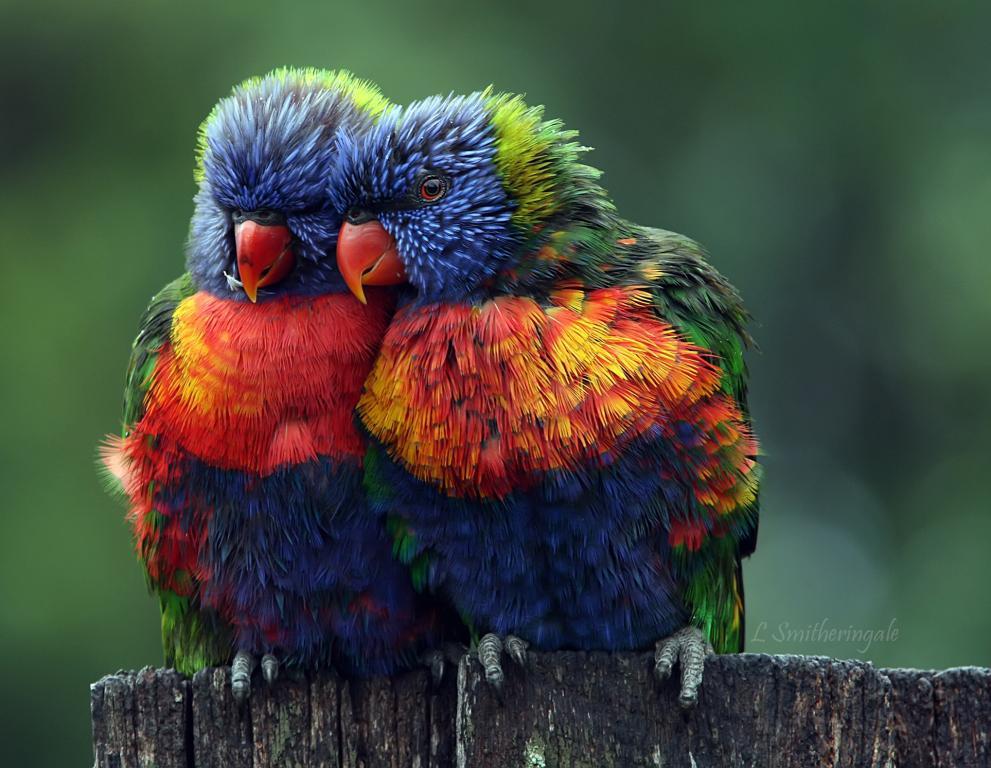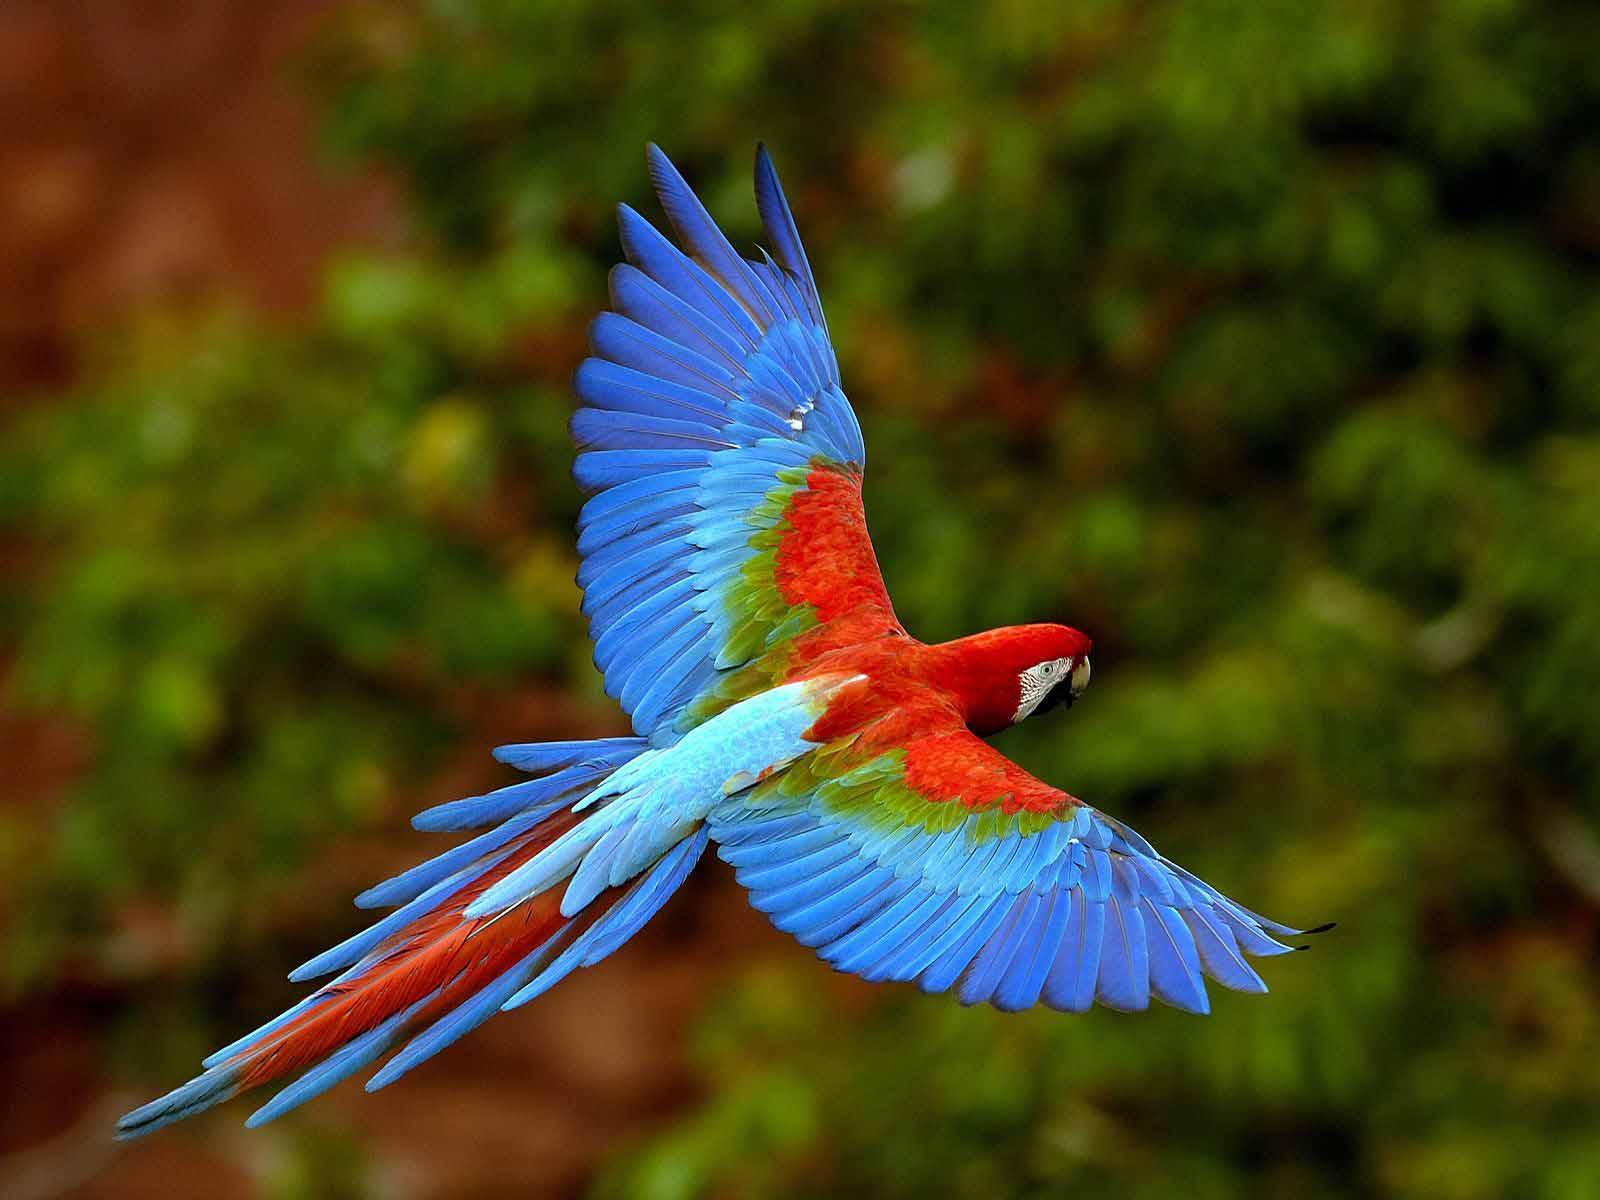The first image is the image on the left, the second image is the image on the right. Evaluate the accuracy of this statement regarding the images: "One image includes a colorful parrot with wide-spread wings.". Is it true? Answer yes or no. Yes. The first image is the image on the left, the second image is the image on the right. Assess this claim about the two images: "One photo shows a colorful bird with its wings spread". Correct or not? Answer yes or no. Yes. 